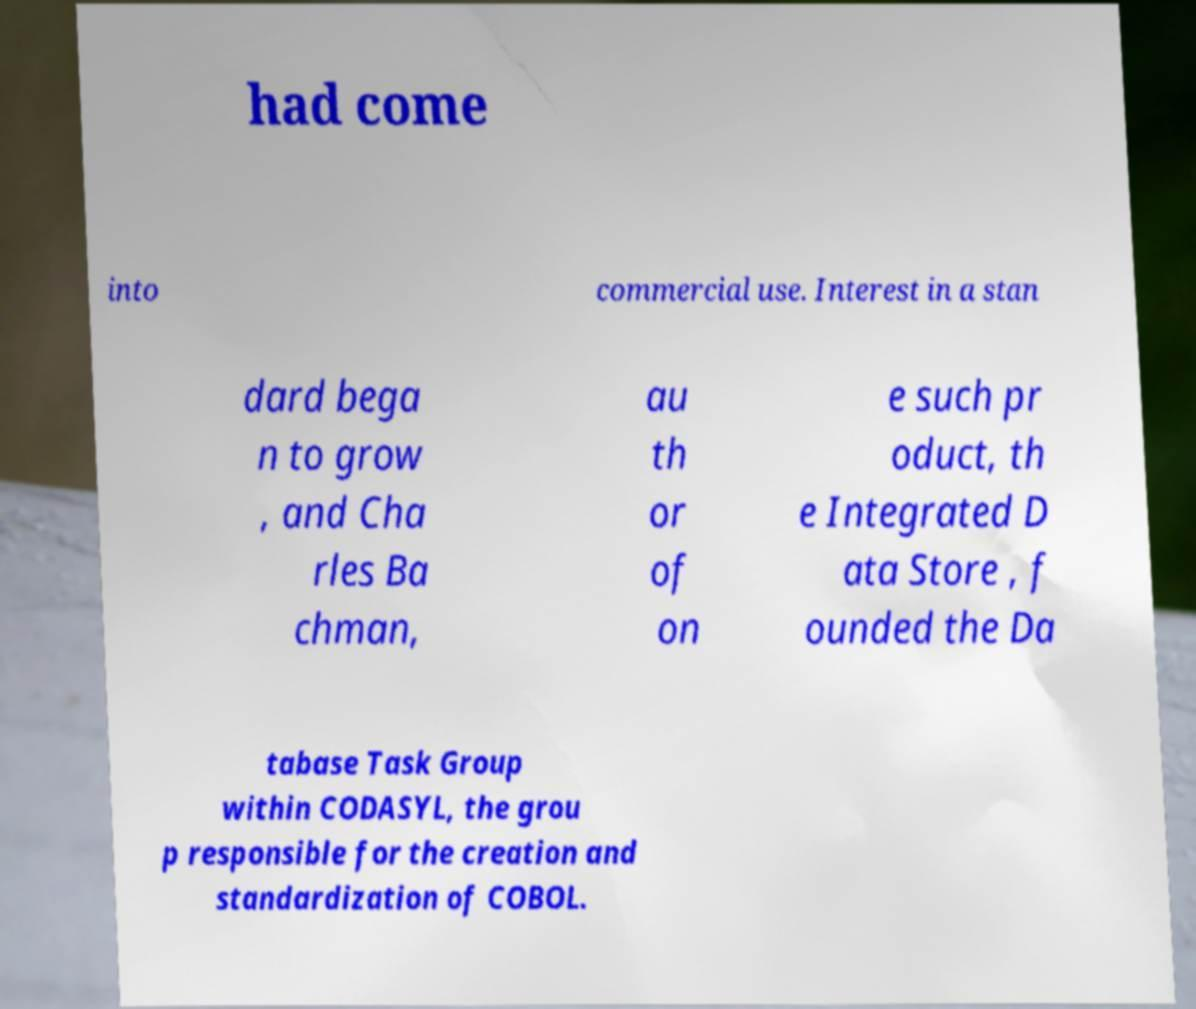For documentation purposes, I need the text within this image transcribed. Could you provide that? had come into commercial use. Interest in a stan dard bega n to grow , and Cha rles Ba chman, au th or of on e such pr oduct, th e Integrated D ata Store , f ounded the Da tabase Task Group within CODASYL, the grou p responsible for the creation and standardization of COBOL. 